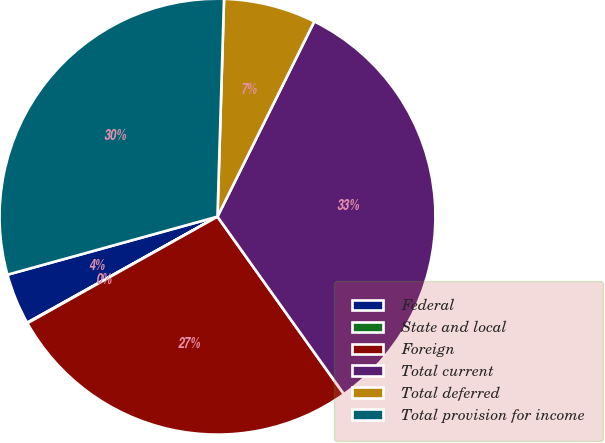Convert chart. <chart><loc_0><loc_0><loc_500><loc_500><pie_chart><fcel>Federal<fcel>State and local<fcel>Foreign<fcel>Total current<fcel>Total deferred<fcel>Total provision for income<nl><fcel>3.8%<fcel>0.04%<fcel>26.72%<fcel>32.82%<fcel>6.85%<fcel>29.77%<nl></chart> 